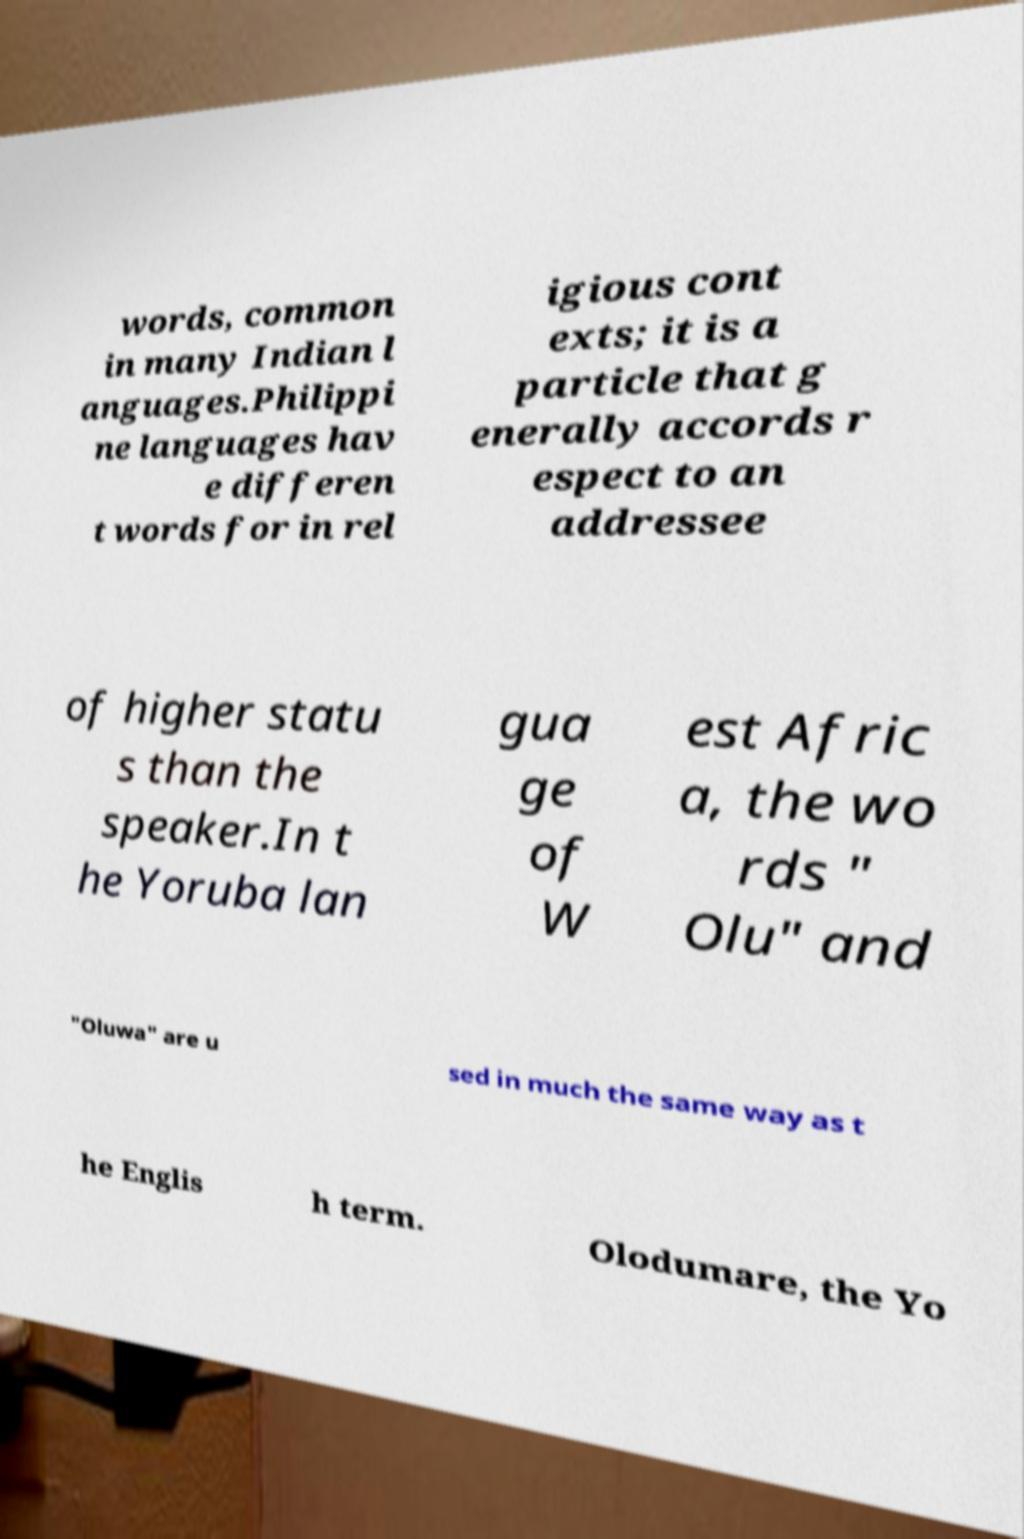Can you read and provide the text displayed in the image?This photo seems to have some interesting text. Can you extract and type it out for me? words, common in many Indian l anguages.Philippi ne languages hav e differen t words for in rel igious cont exts; it is a particle that g enerally accords r espect to an addressee of higher statu s than the speaker.In t he Yoruba lan gua ge of W est Afric a, the wo rds " Olu" and "Oluwa" are u sed in much the same way as t he Englis h term. Olodumare, the Yo 